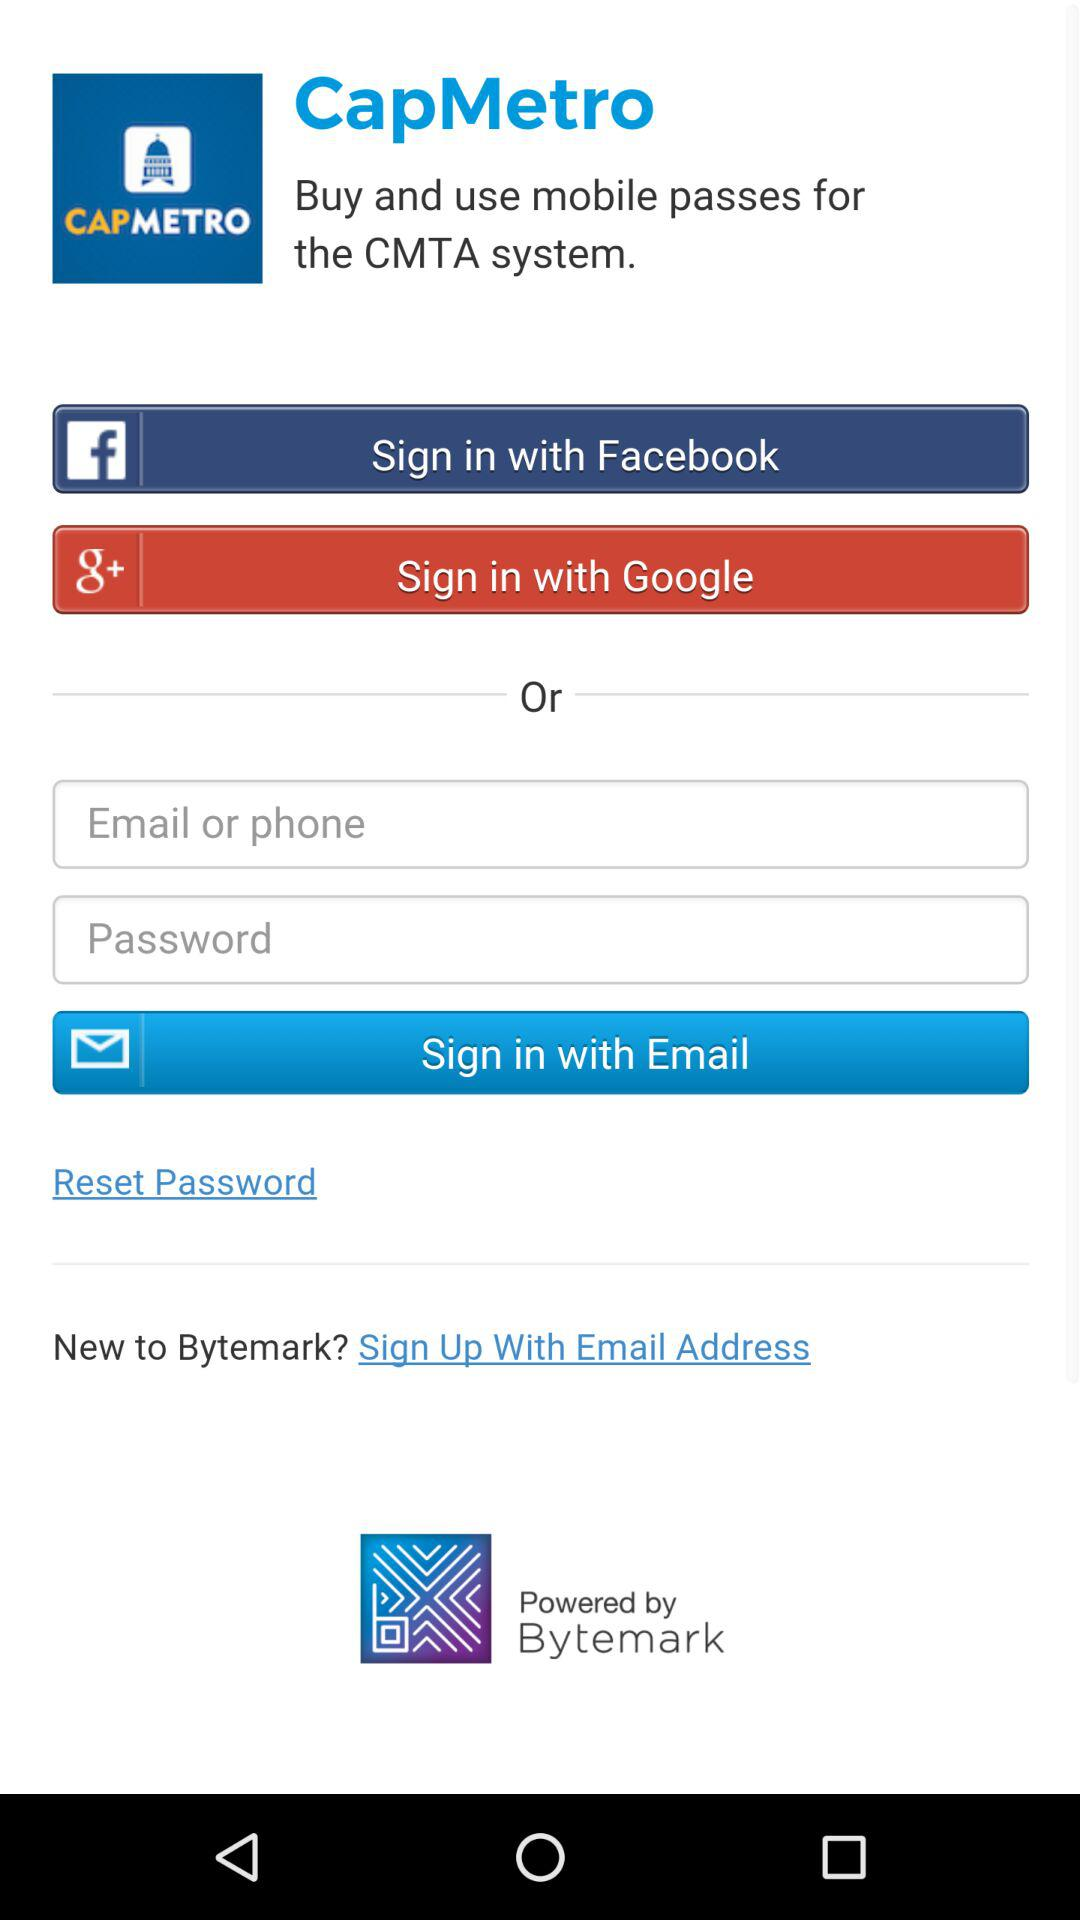What is the application name? The application name is "CapMetro". 